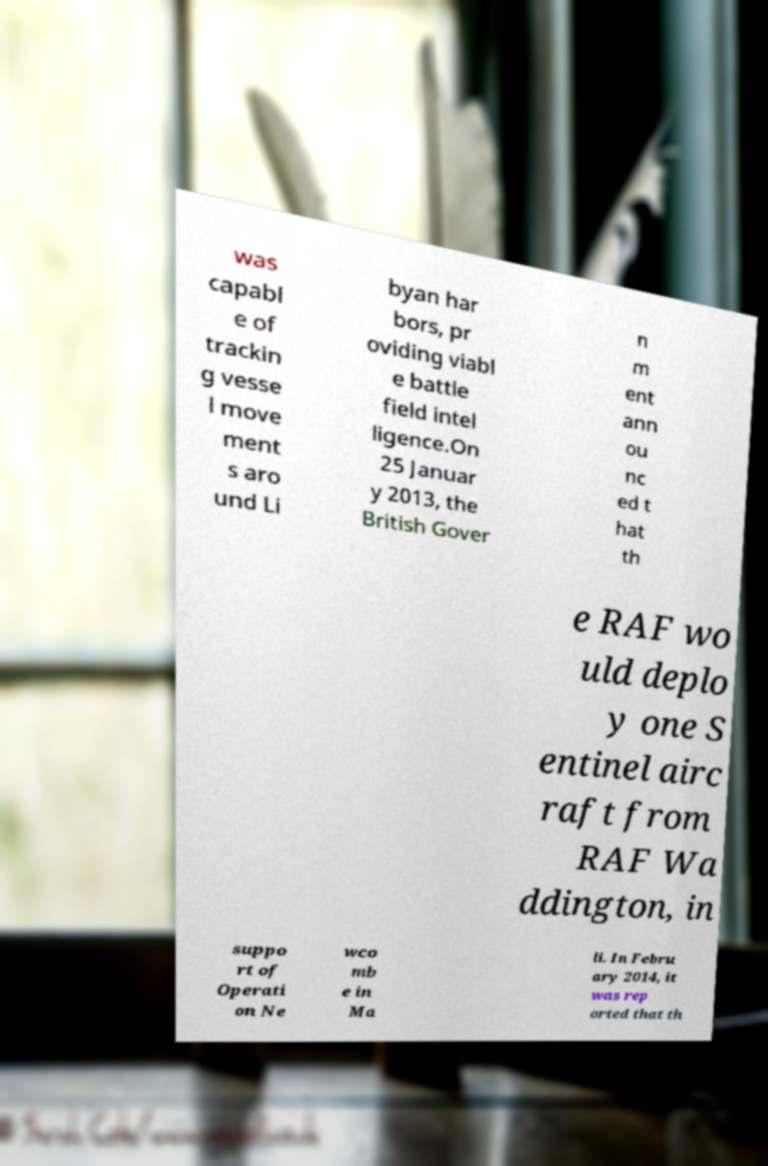Can you accurately transcribe the text from the provided image for me? was capabl e of trackin g vesse l move ment s aro und Li byan har bors, pr oviding viabl e battle field intel ligence.On 25 Januar y 2013, the British Gover n m ent ann ou nc ed t hat th e RAF wo uld deplo y one S entinel airc raft from RAF Wa ddington, in suppo rt of Operati on Ne wco mb e in Ma li. In Febru ary 2014, it was rep orted that th 